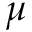Convert formula to latex. <formula><loc_0><loc_0><loc_500><loc_500>\mu</formula> 